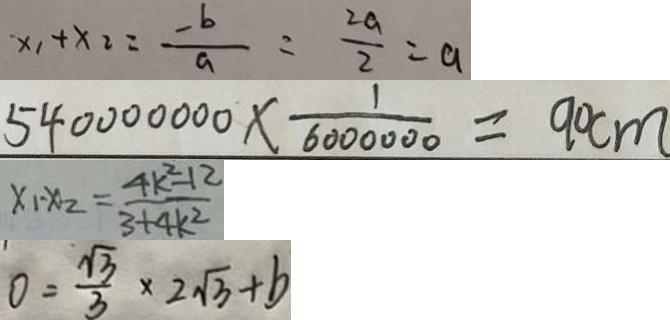<formula> <loc_0><loc_0><loc_500><loc_500>x _ { 1 } + x _ { 2 } = \frac { - b } { a } = \frac { 2 a } { 2 } = a 
 5 4 0 0 0 0 0 0 0 \times \frac { 1 } { 6 0 0 0 0 0 0 } = 9 0 c m 
 x _ { 1 } - x _ { 2 } = \frac { 4 k ^ { 2 } - 1 2 } { 3 + 4 k ^ { 2 } } 
 0 = \frac { \sqrt { 3 } } { 3 } \times 2 \sqrt { 3 } + b</formula> 